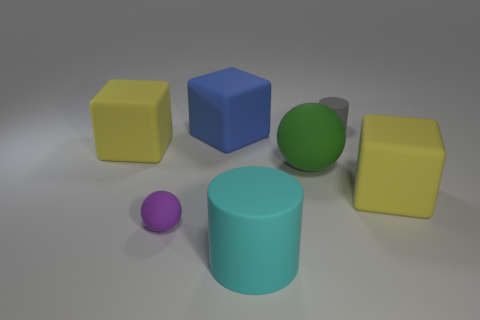What number of matte objects are either yellow cylinders or tiny cylinders?
Your answer should be compact. 1. The cylinder in front of the yellow matte thing that is on the left side of the big rubber sphere that is right of the cyan rubber object is what color?
Make the answer very short. Cyan. There is a large rubber object that is the same shape as the tiny purple thing; what color is it?
Ensure brevity in your answer.  Green. Is there any other thing that is the same color as the tiny sphere?
Offer a terse response. No. What number of other things are there of the same material as the big sphere
Your answer should be compact. 6. The cyan thing has what size?
Provide a succinct answer. Large. Are there any small purple metal objects of the same shape as the green rubber thing?
Your response must be concise. No. What number of things are tiny red shiny spheres or big rubber blocks left of the cyan matte cylinder?
Make the answer very short. 2. There is a small object that is to the left of the cyan matte thing; what color is it?
Provide a short and direct response. Purple. Does the sphere on the right side of the cyan thing have the same size as the yellow rubber thing that is to the left of the blue thing?
Provide a short and direct response. Yes. 